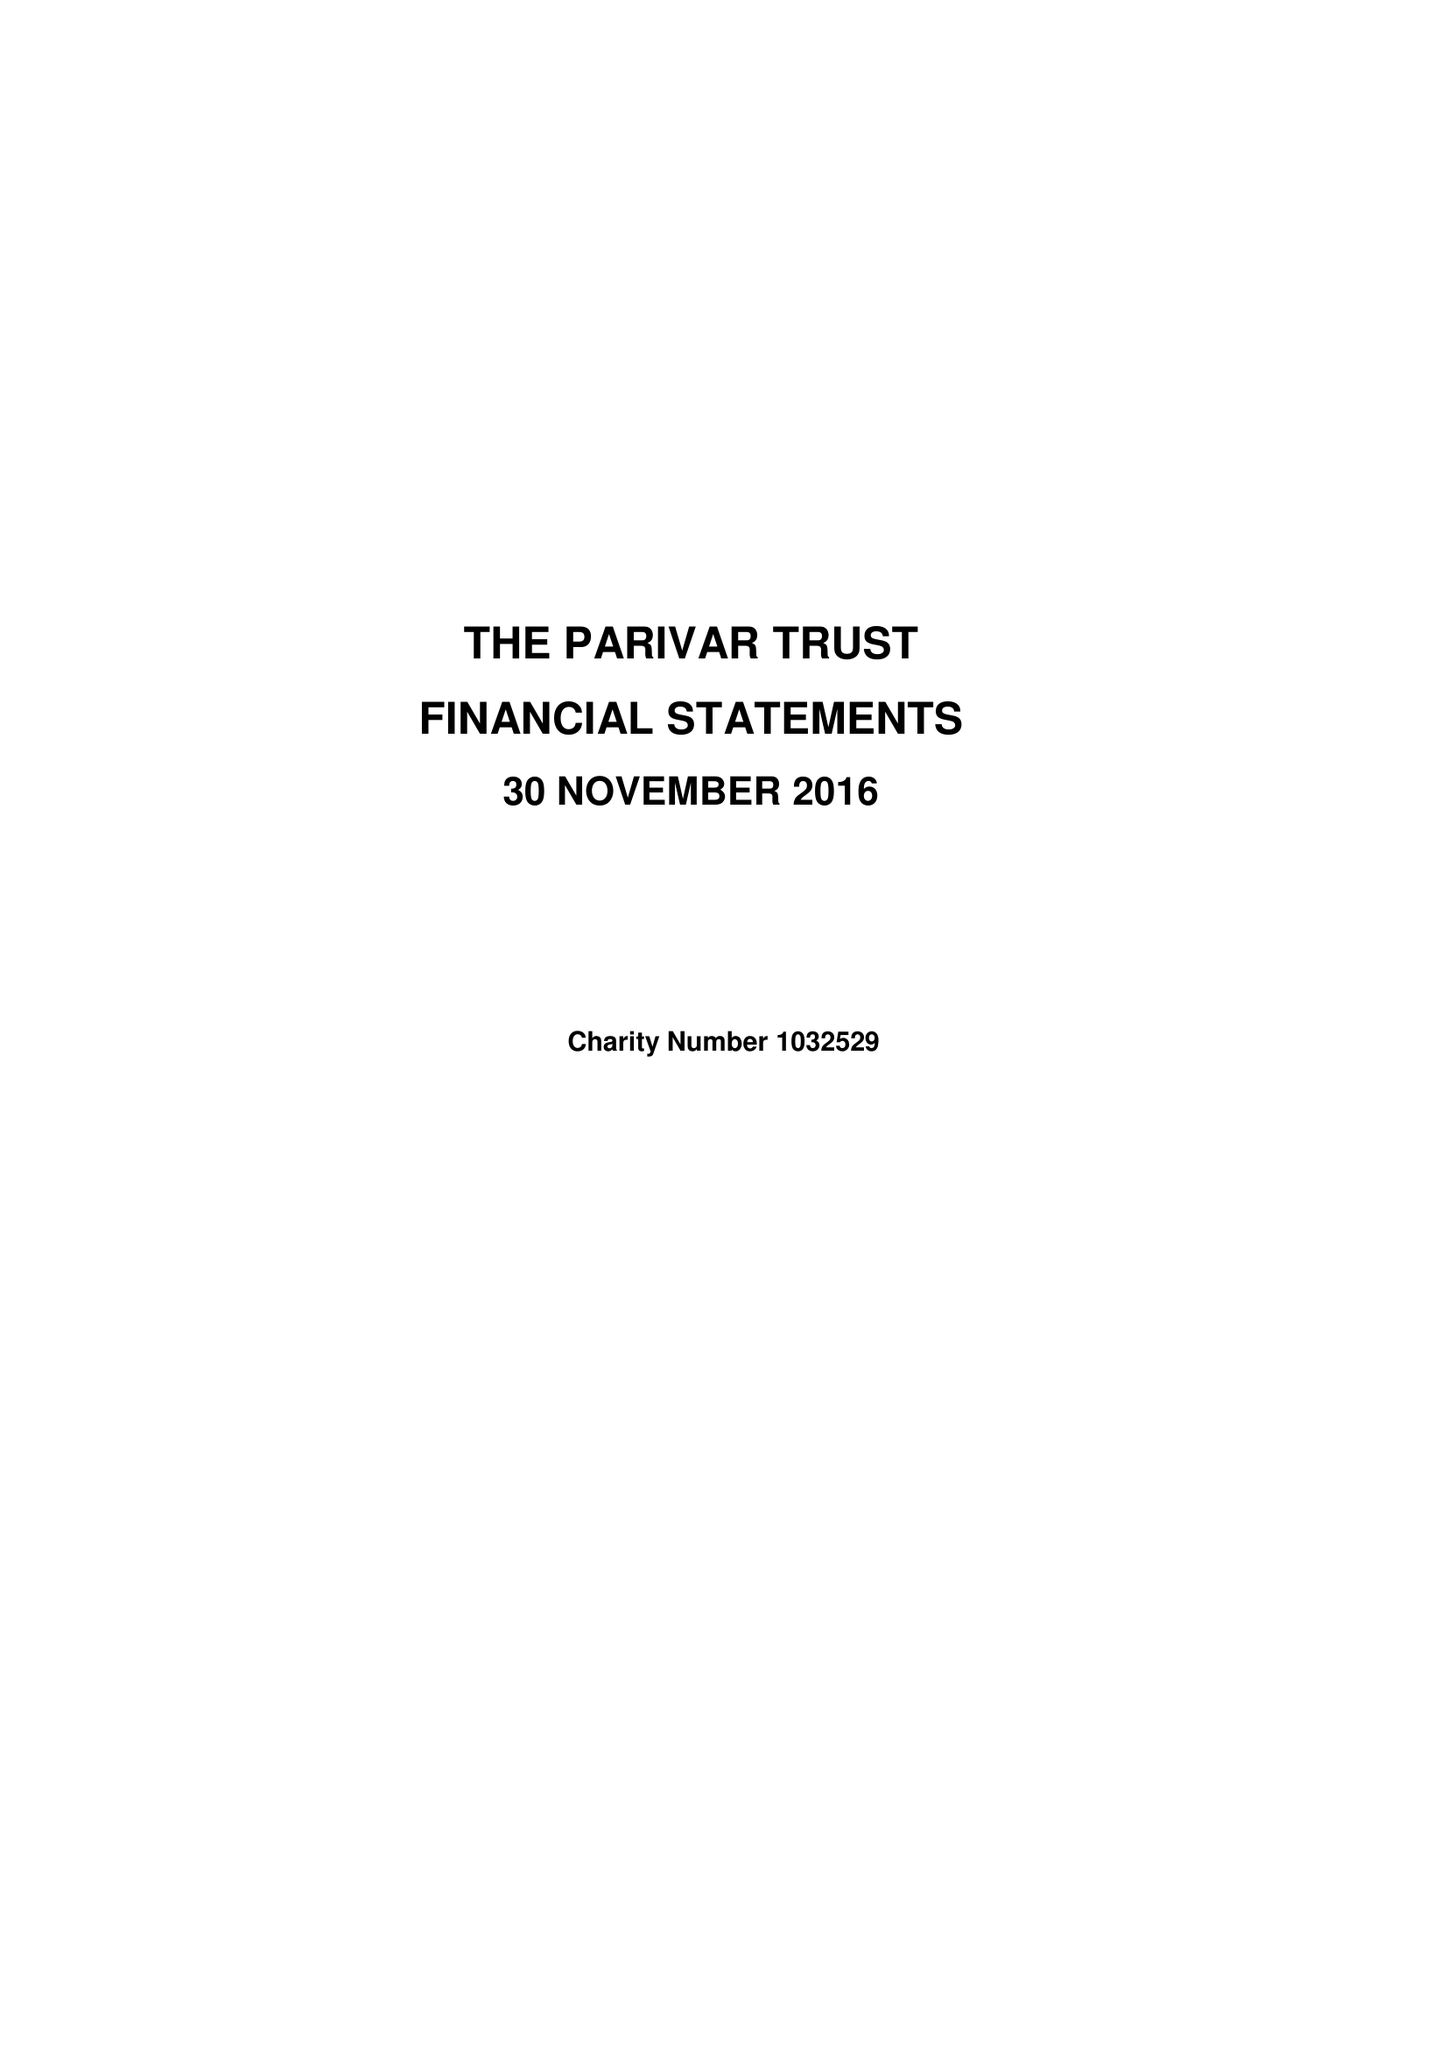What is the value for the address__post_town?
Answer the question using a single word or phrase. HEREFORD 